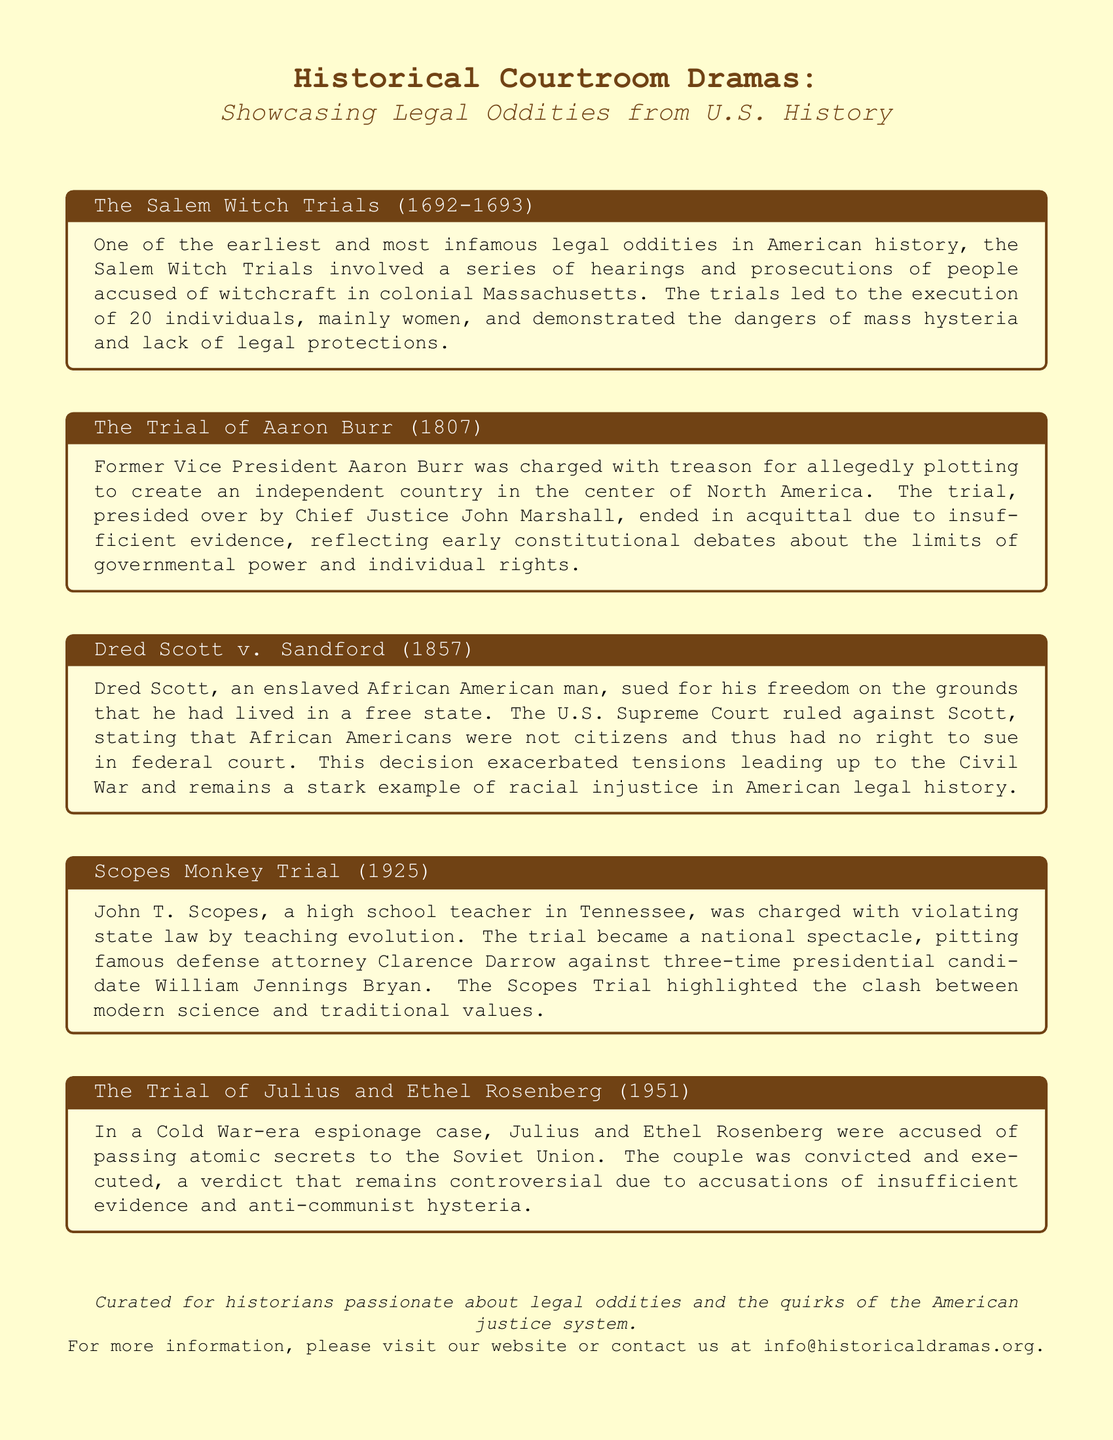What trial took place between 1692 and 1693? The document mentions the Salem Witch Trials, which occurred during this time.
Answer: Salem Witch Trials Who was acquitted in the trial of treason? The document states that Aaron Burr was acquitted due to insufficient evidence in his treason trial.
Answer: Aaron Burr What was the ruling in Dred Scott v. Sandford? The document states that the U.S. Supreme Court ruled against Dred Scott, declaring that African Americans were not citizens.
Answer: Against Dred Scott In what year was the Scopes Monkey Trial? The document indicates that the Scopes Monkey Trial took place in 1925.
Answer: 1925 What was the primary charge against Julius and Ethel Rosenberg? The document describes them as being accused of passing atomic secrets to the Soviet Union.
Answer: Espionage What theme is common in the trials mentioned in the document? The document discusses legal oddities, reflecting themes of injustice and societal conflict.
Answer: Legal oddities Who were the opposing lawyers in the Scopes Monkey Trial? The document notes that Clarence Darrow defended Scopes against William Jennings Bryan.
Answer: Clarence Darrow and William Jennings Bryan What is the overarching focus of the document? The title and introductory text specify that it showcases historical courtroom dramas linked to legal oddities in U.S. history.
Answer: Historical courtroom dramas 